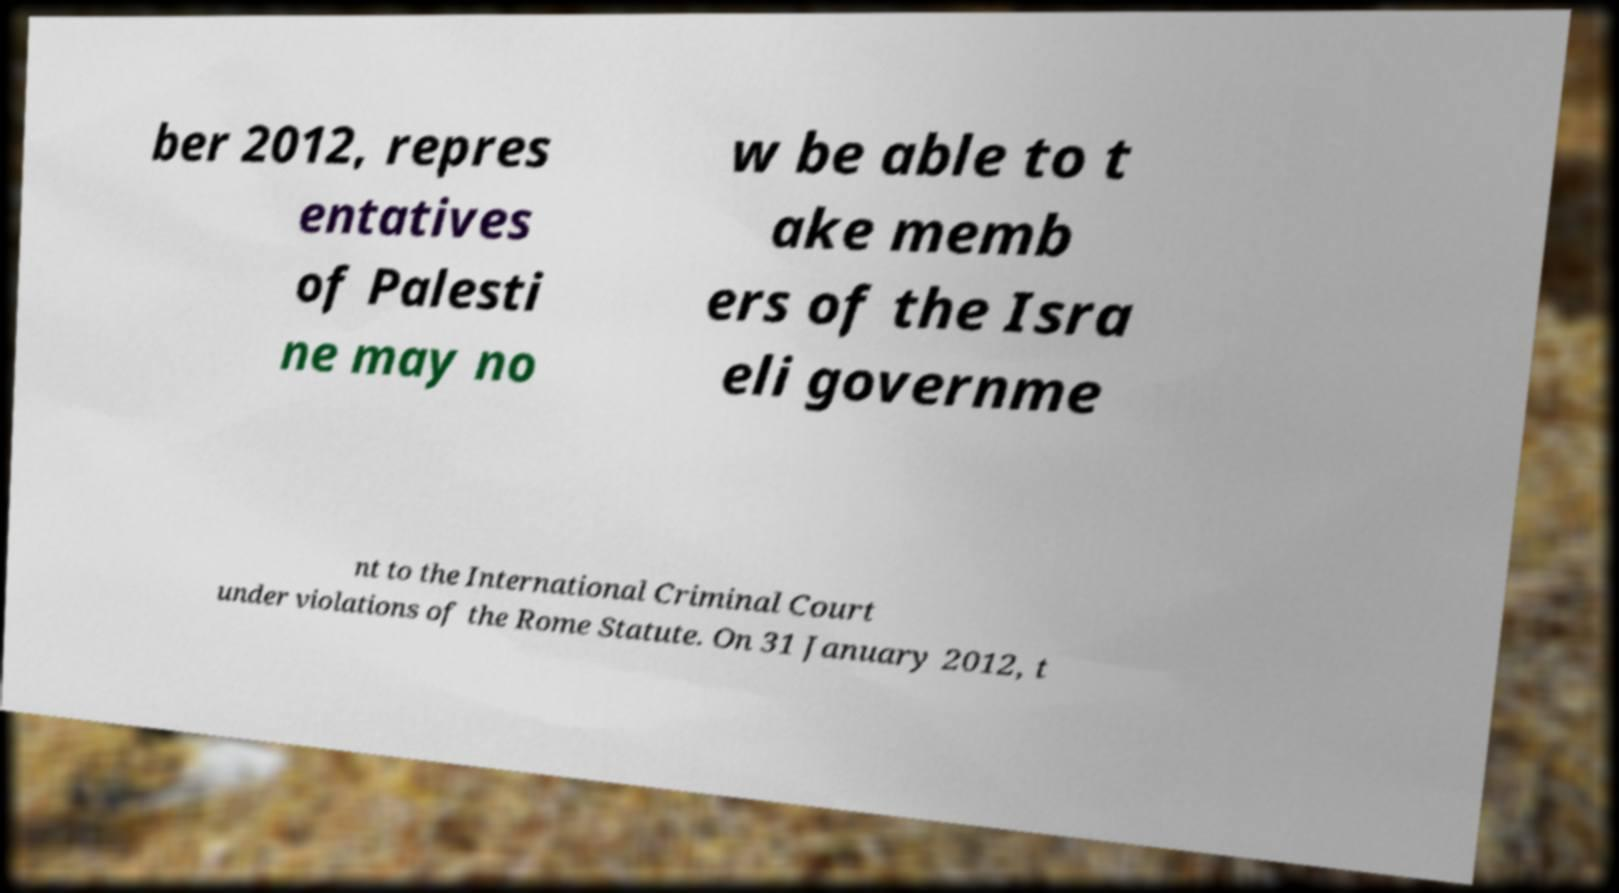What messages or text are displayed in this image? I need them in a readable, typed format. ber 2012, repres entatives of Palesti ne may no w be able to t ake memb ers of the Isra eli governme nt to the International Criminal Court under violations of the Rome Statute. On 31 January 2012, t 